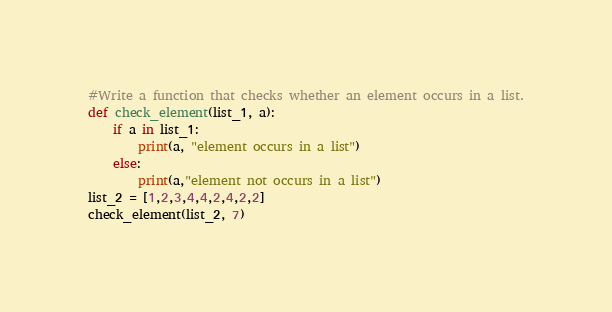Convert code to text. <code><loc_0><loc_0><loc_500><loc_500><_Python_>#Write a function that checks whether an element occurs in a list.
def check_element(list_1, a):
    if a in list_1:
        print(a, "element occurs in a list")
    else:
        print(a,"element not occurs in a list")
list_2 = [1,2,3,4,4,2,4,2,2]
check_element(list_2, 7)
</code> 